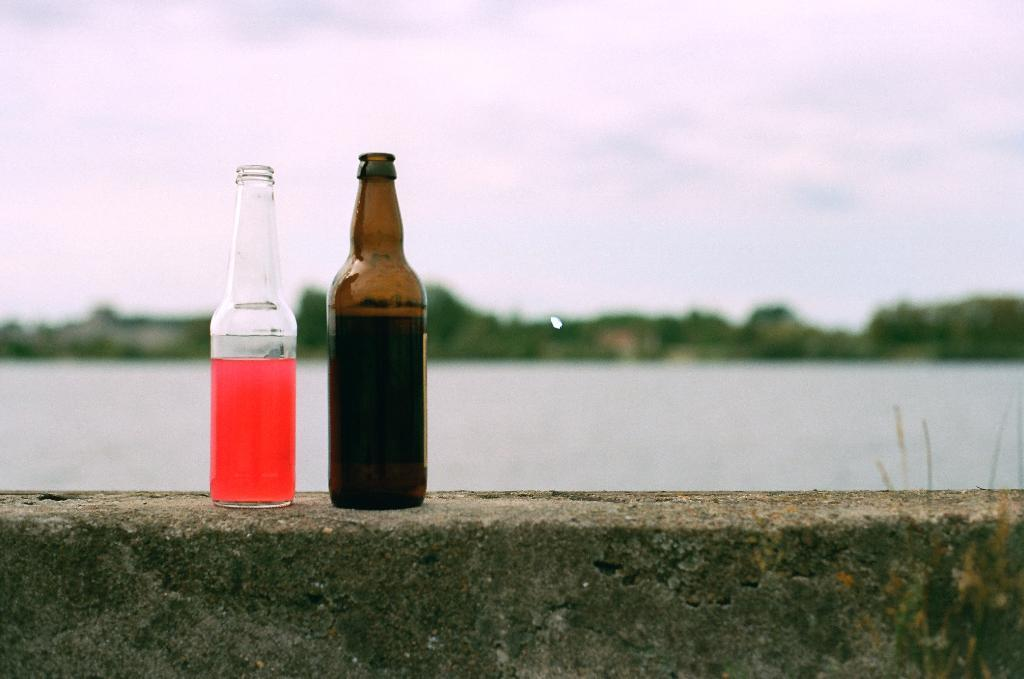How many wine bottles are visible in the image? There are two wine bottles in the image. Where are the wine bottles placed? The wine bottles are kept on a rock. What can be seen in the background of the image? There is a lake in the background of the image. What is the condition of the sky in the image? The sky is clear in the image. What is the tendency of the plot to affect the wine bottles in the image? There is no plot present in the image, as it is a photograph of wine bottles on a rock with a lake and clear sky in the background. 